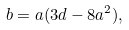Convert formula to latex. <formula><loc_0><loc_0><loc_500><loc_500>b = a ( 3 d - 8 a ^ { 2 } ) ,</formula> 